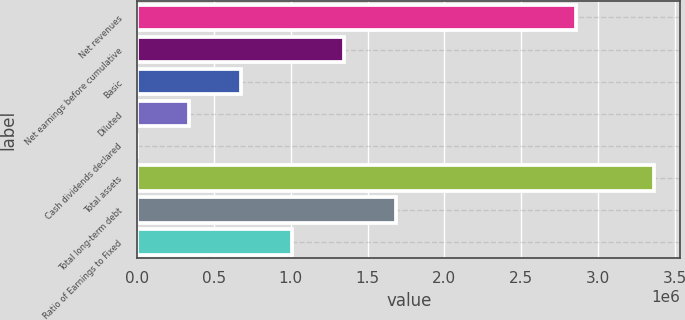Convert chart. <chart><loc_0><loc_0><loc_500><loc_500><bar_chart><fcel>Net revenues<fcel>Net earnings before cumulative<fcel>Basic<fcel>Diluted<fcel>Cash dividends declared<fcel>Total assets<fcel>Total long-term debt<fcel>Ratio of Earnings to Fixed<nl><fcel>2.85634e+06<fcel>1.34759e+06<fcel>673796<fcel>336898<fcel>0.12<fcel>3.36898e+06<fcel>1.68449e+06<fcel>1.01069e+06<nl></chart> 